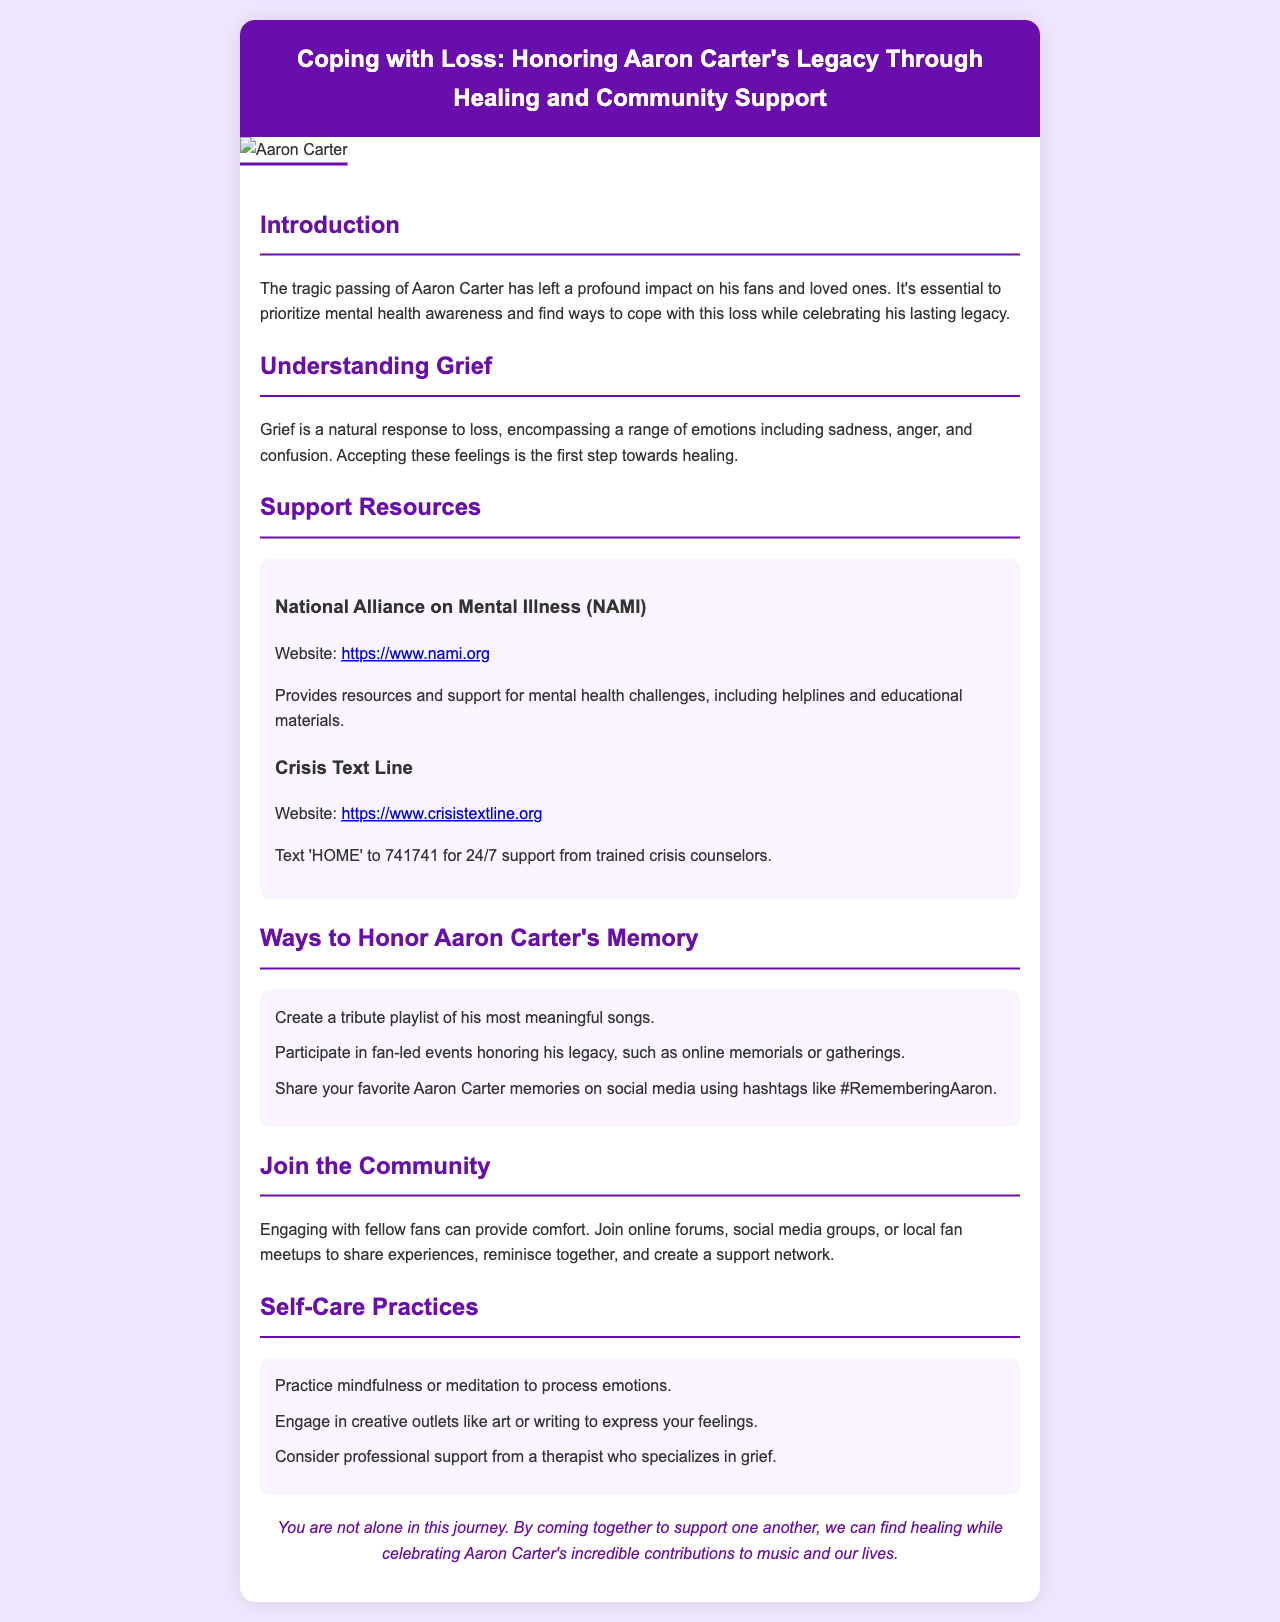What is the title of the brochure? The title is presented prominently at the top of the document.
Answer: Coping with Loss: Honoring Aaron Carter's Legacy Through Healing and Community Support What organization provides mental health resources listed in the brochure? The resource section highlights specific organizations, including one for mental health challenges.
Answer: National Alliance on Mental Illness (NAMI) What text should you send for 24/7 support from Crisis Text Line? The document specifies the text to send for accessing support.
Answer: HOME What is one way to honor Aaron Carter's memory mentioned in the brochure? The honor section lists several ways to remember Aaron Carter.
Answer: Create a tribute playlist of his most meaningful songs What can engaging with fellow fans provide according to the document? The joining community section discusses the benefits of connecting with others.
Answer: Comfort What type of self-care practice is suggested in the brochure? The self-care practices section provides specific suggestions for coping.
Answer: Mindfulness How many self-care practices are listed in the document? The number of items in the self-care section indicates the variety offered.
Answer: Three What color is used for the header background? The header color is stated in the style section of the document.
Answer: #6a0dad 